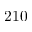<formula> <loc_0><loc_0><loc_500><loc_500>2 1 0</formula> 